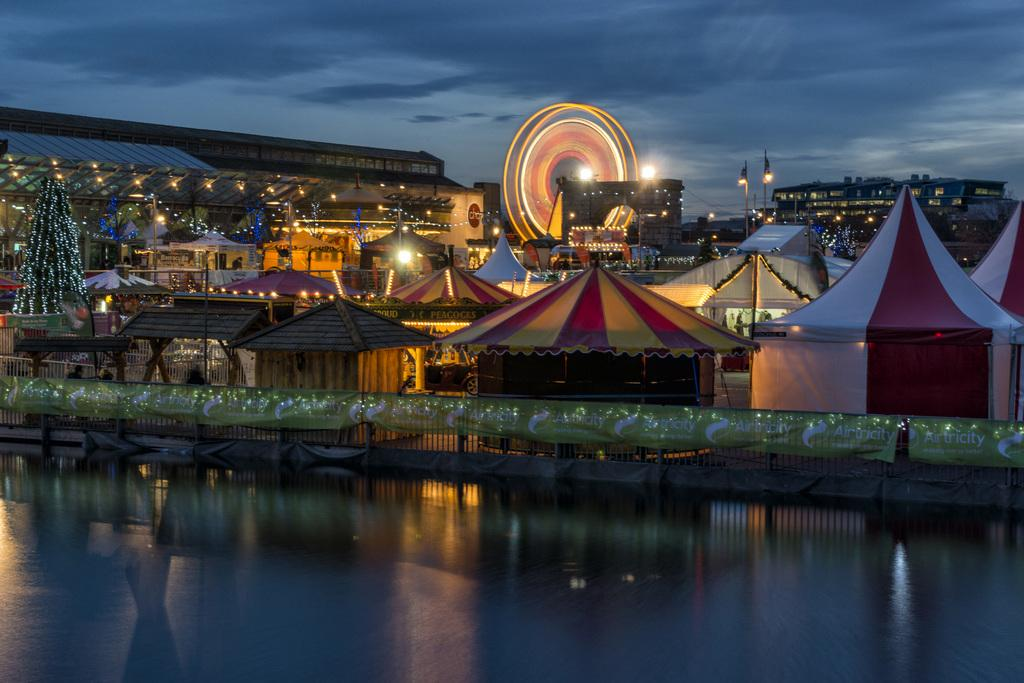What type of natural feature can be seen in the image? There is a lake in the image. What type of temporary shelter is visible in the image? There are tents in the image. What type of man-made structures can be seen in the image? There are buildings in the image. What type of vegetation is present in the image? There are trees in the image. What other objects can be seen in the image? There are other objects in the image. Where is the alley located in the image? There is no alley present in the image. What type of musical instrument is being played in the image? There is no musical instrument or drum being played in the image. 